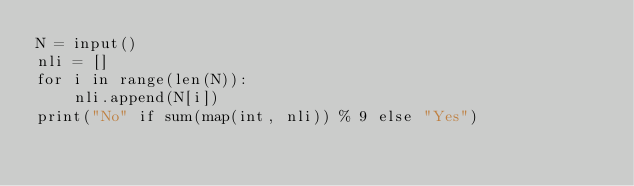Convert code to text. <code><loc_0><loc_0><loc_500><loc_500><_Python_>N = input()
nli = []
for i in range(len(N)):
    nli.append(N[i])
print("No" if sum(map(int, nli)) % 9 else "Yes")</code> 